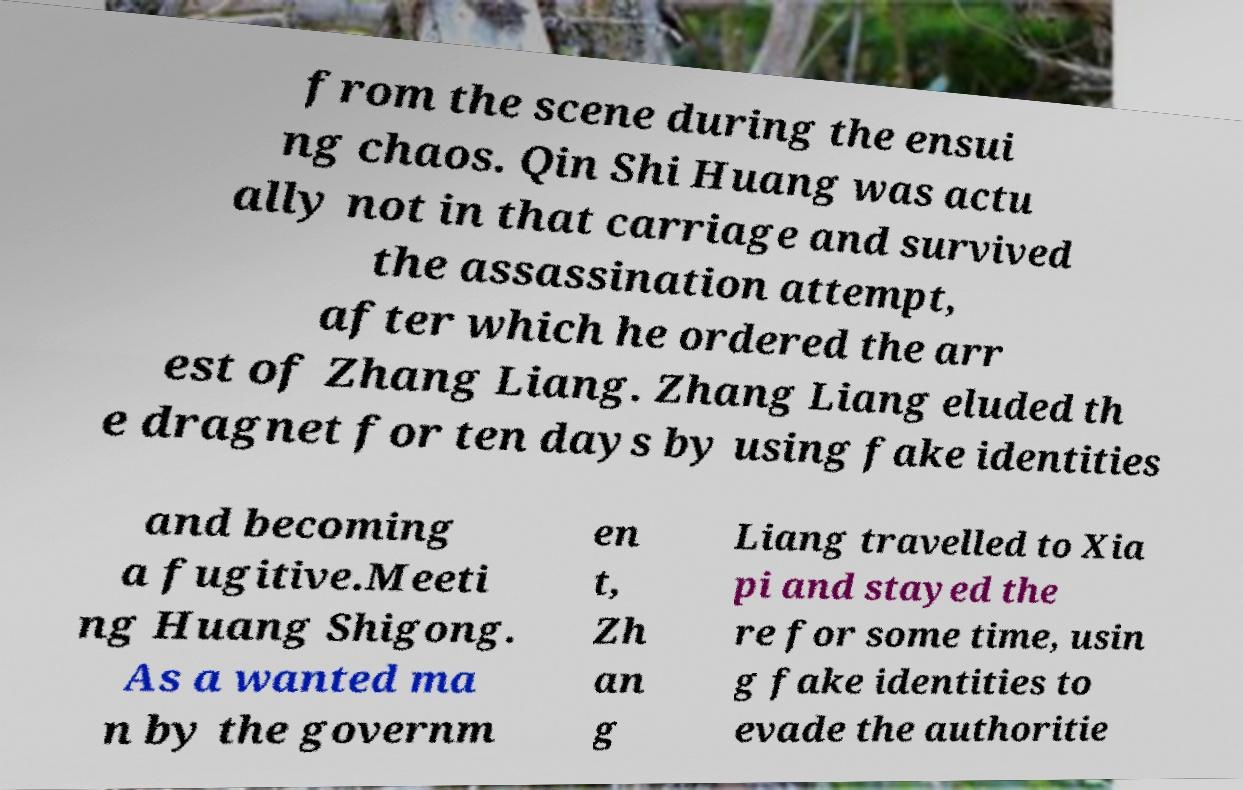There's text embedded in this image that I need extracted. Can you transcribe it verbatim? from the scene during the ensui ng chaos. Qin Shi Huang was actu ally not in that carriage and survived the assassination attempt, after which he ordered the arr est of Zhang Liang. Zhang Liang eluded th e dragnet for ten days by using fake identities and becoming a fugitive.Meeti ng Huang Shigong. As a wanted ma n by the governm en t, Zh an g Liang travelled to Xia pi and stayed the re for some time, usin g fake identities to evade the authoritie 